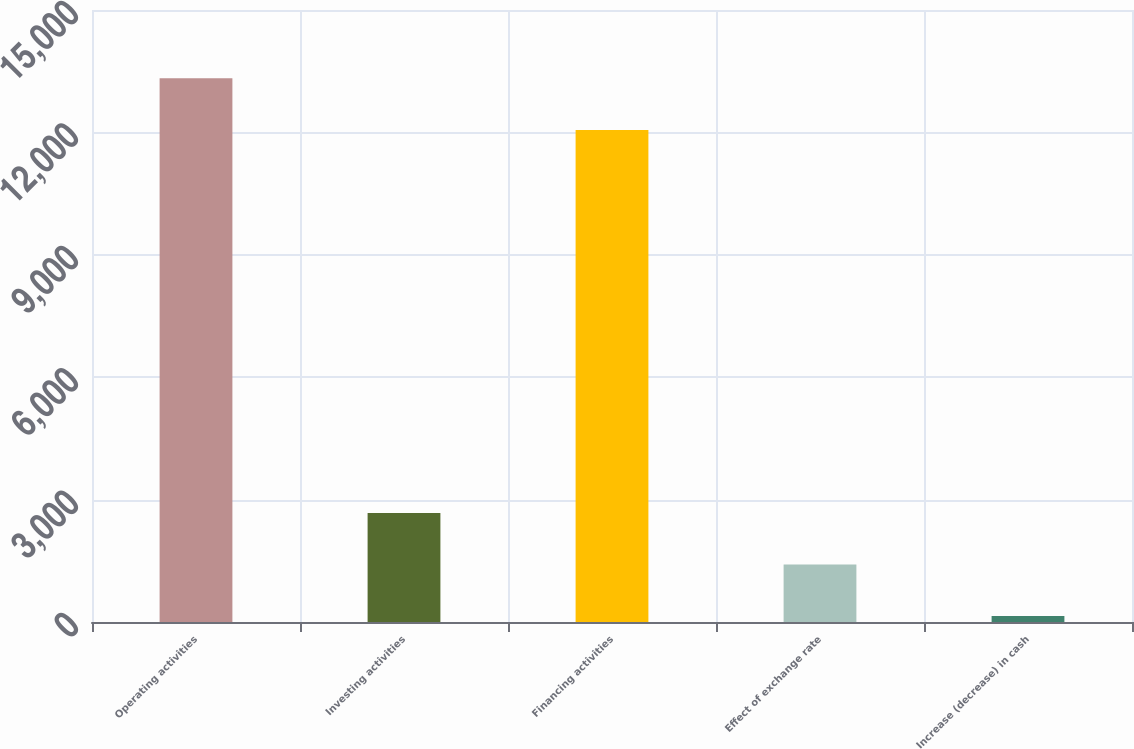Convert chart. <chart><loc_0><loc_0><loc_500><loc_500><bar_chart><fcel>Operating activities<fcel>Investing activities<fcel>Financing activities<fcel>Effect of exchange rate<fcel>Increase (decrease) in cash<nl><fcel>13324.9<fcel>2672.8<fcel>12061<fcel>1408.9<fcel>145<nl></chart> 